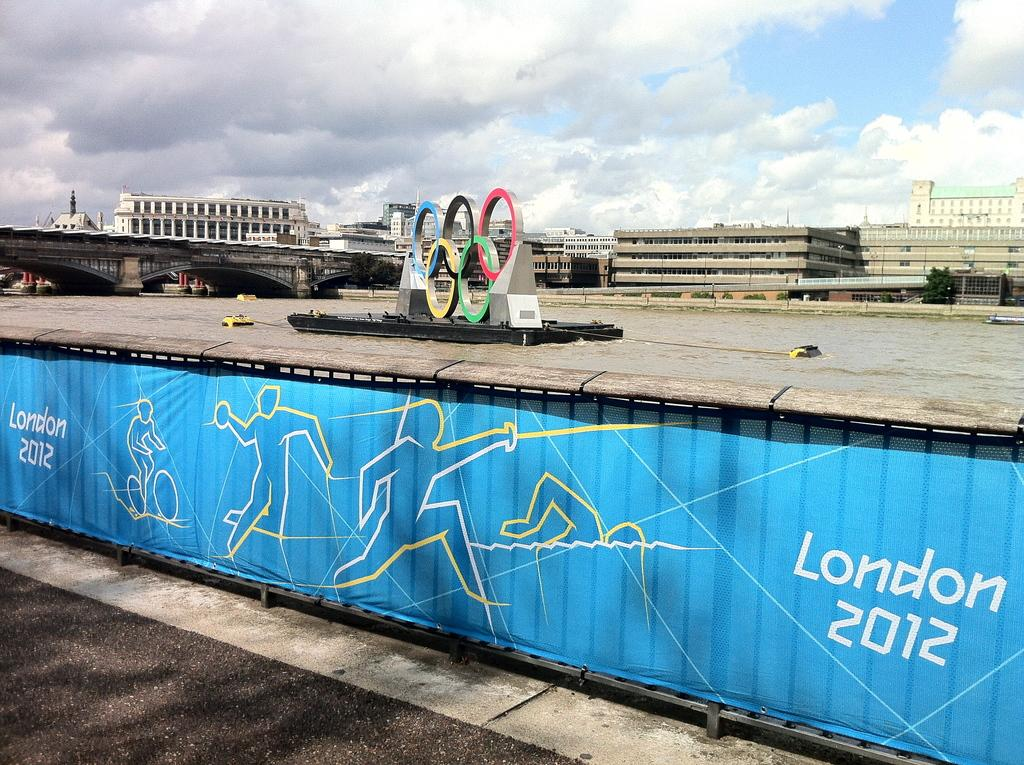What is attached to the fencing in the image? There is a banner attached to the fencing in the image. What can be seen on the water surface in the image? There are boats on the water surface in the image. What type of structures can be seen in the background of the image? There are buildings, trees, and bridges visible in the background of the image. What type of tax is being collected from the boats in the image? There is no mention of tax collection in the image; it features boats on the water surface. What material is the tiger is made of in the image? There is no tiger present in the image. 